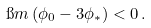Convert formula to latex. <formula><loc_0><loc_0><loc_500><loc_500>\i m \left ( \phi _ { 0 } - 3 \phi _ { * } \right ) < 0 \, .</formula> 